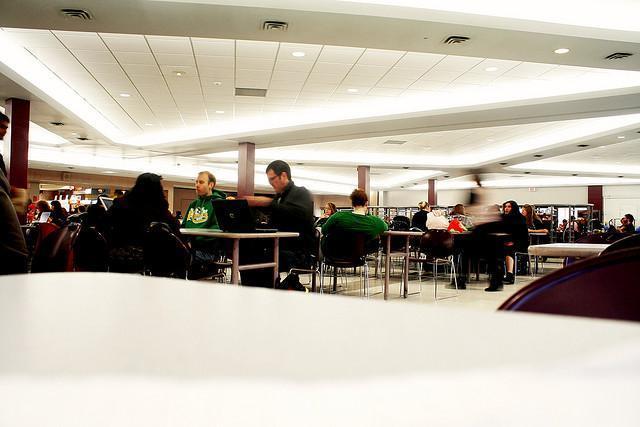How many people are sitting at the table to the left?
Give a very brief answer. 3. How many people can you see?
Give a very brief answer. 2. How many zebras are grazing?
Give a very brief answer. 0. 